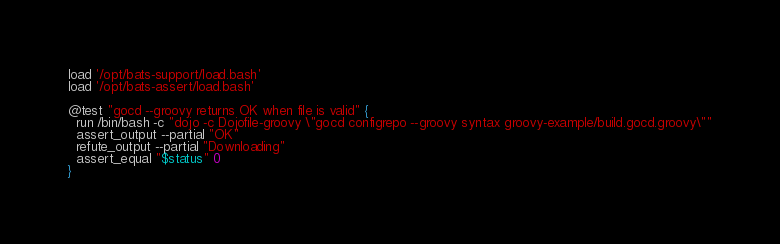Convert code to text. <code><loc_0><loc_0><loc_500><loc_500><_Bash_>load '/opt/bats-support/load.bash'
load '/opt/bats-assert/load.bash'

@test "gocd --groovy returns OK when file is valid" {
  run /bin/bash -c "dojo -c Dojofile-groovy \"gocd configrepo --groovy syntax groovy-example/build.gocd.groovy\""
  assert_output --partial "OK"
  refute_output --partial "Downloading"
  assert_equal "$status" 0
}
</code> 